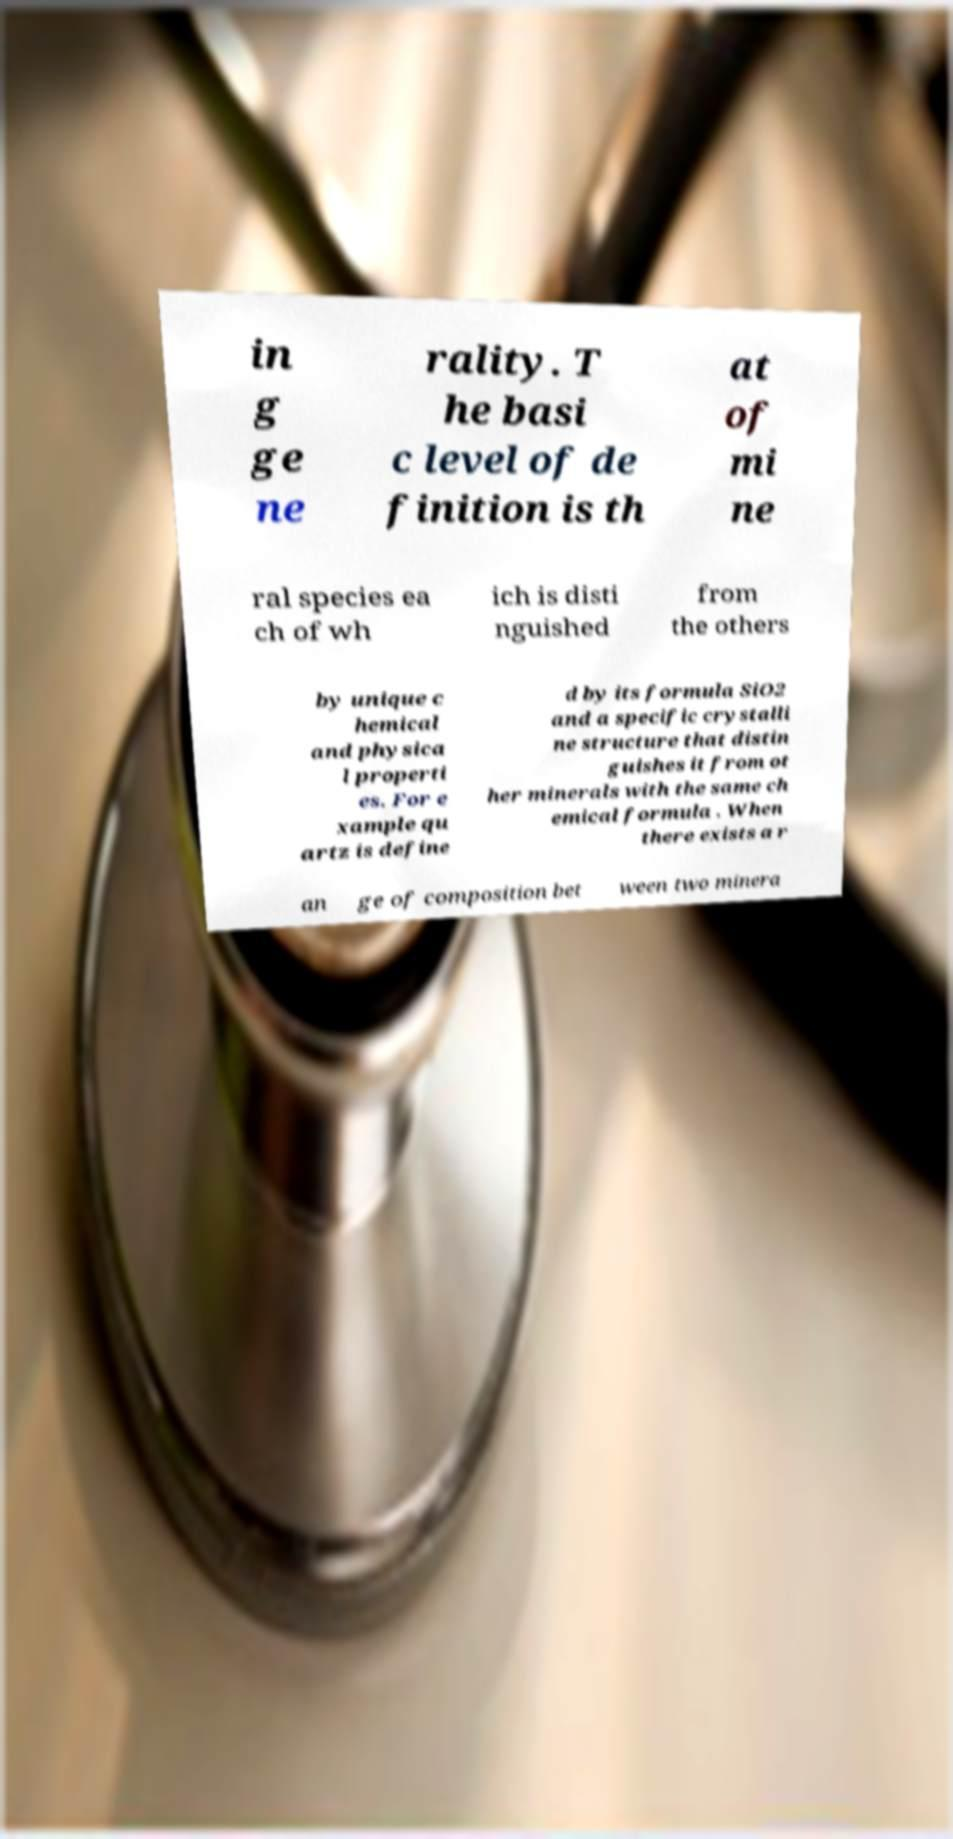Can you read and provide the text displayed in the image?This photo seems to have some interesting text. Can you extract and type it out for me? in g ge ne rality. T he basi c level of de finition is th at of mi ne ral species ea ch of wh ich is disti nguished from the others by unique c hemical and physica l properti es. For e xample qu artz is define d by its formula SiO2 and a specific crystalli ne structure that distin guishes it from ot her minerals with the same ch emical formula . When there exists a r an ge of composition bet ween two minera 